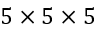<formula> <loc_0><loc_0><loc_500><loc_500>5 \times 5 \times 5</formula> 